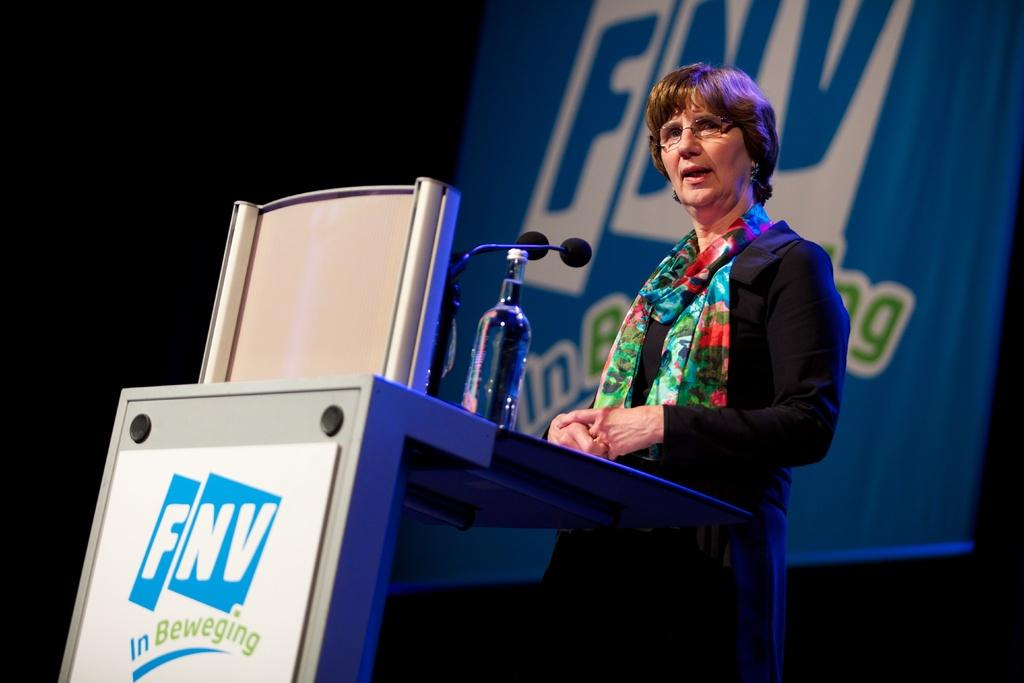Who is the main subject in the image? There is a woman in the image. What is the woman doing in the image? The woman is speaking on a microphone. Where is the woman located in the image? The woman is standing in front of a desk. What type of food is the woman cooking in the image? There is no indication in the image that the woman is cooking any food, as she is speaking on a microphone and standing in front of a desk. 